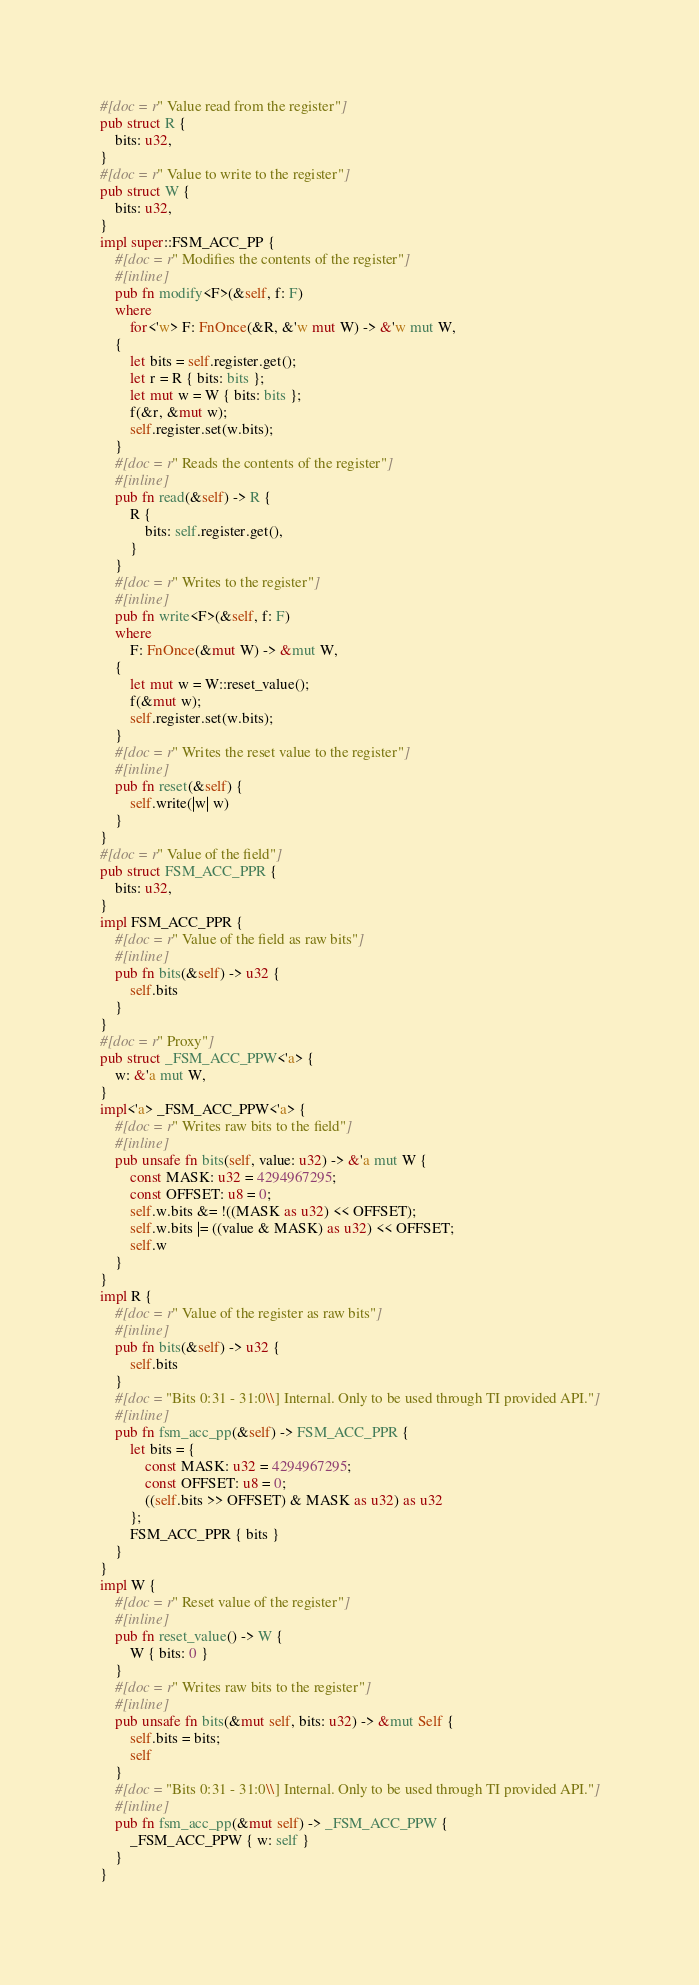<code> <loc_0><loc_0><loc_500><loc_500><_Rust_>#[doc = r" Value read from the register"]
pub struct R {
    bits: u32,
}
#[doc = r" Value to write to the register"]
pub struct W {
    bits: u32,
}
impl super::FSM_ACC_PP {
    #[doc = r" Modifies the contents of the register"]
    #[inline]
    pub fn modify<F>(&self, f: F)
    where
        for<'w> F: FnOnce(&R, &'w mut W) -> &'w mut W,
    {
        let bits = self.register.get();
        let r = R { bits: bits };
        let mut w = W { bits: bits };
        f(&r, &mut w);
        self.register.set(w.bits);
    }
    #[doc = r" Reads the contents of the register"]
    #[inline]
    pub fn read(&self) -> R {
        R {
            bits: self.register.get(),
        }
    }
    #[doc = r" Writes to the register"]
    #[inline]
    pub fn write<F>(&self, f: F)
    where
        F: FnOnce(&mut W) -> &mut W,
    {
        let mut w = W::reset_value();
        f(&mut w);
        self.register.set(w.bits);
    }
    #[doc = r" Writes the reset value to the register"]
    #[inline]
    pub fn reset(&self) {
        self.write(|w| w)
    }
}
#[doc = r" Value of the field"]
pub struct FSM_ACC_PPR {
    bits: u32,
}
impl FSM_ACC_PPR {
    #[doc = r" Value of the field as raw bits"]
    #[inline]
    pub fn bits(&self) -> u32 {
        self.bits
    }
}
#[doc = r" Proxy"]
pub struct _FSM_ACC_PPW<'a> {
    w: &'a mut W,
}
impl<'a> _FSM_ACC_PPW<'a> {
    #[doc = r" Writes raw bits to the field"]
    #[inline]
    pub unsafe fn bits(self, value: u32) -> &'a mut W {
        const MASK: u32 = 4294967295;
        const OFFSET: u8 = 0;
        self.w.bits &= !((MASK as u32) << OFFSET);
        self.w.bits |= ((value & MASK) as u32) << OFFSET;
        self.w
    }
}
impl R {
    #[doc = r" Value of the register as raw bits"]
    #[inline]
    pub fn bits(&self) -> u32 {
        self.bits
    }
    #[doc = "Bits 0:31 - 31:0\\] Internal. Only to be used through TI provided API."]
    #[inline]
    pub fn fsm_acc_pp(&self) -> FSM_ACC_PPR {
        let bits = {
            const MASK: u32 = 4294967295;
            const OFFSET: u8 = 0;
            ((self.bits >> OFFSET) & MASK as u32) as u32
        };
        FSM_ACC_PPR { bits }
    }
}
impl W {
    #[doc = r" Reset value of the register"]
    #[inline]
    pub fn reset_value() -> W {
        W { bits: 0 }
    }
    #[doc = r" Writes raw bits to the register"]
    #[inline]
    pub unsafe fn bits(&mut self, bits: u32) -> &mut Self {
        self.bits = bits;
        self
    }
    #[doc = "Bits 0:31 - 31:0\\] Internal. Only to be used through TI provided API."]
    #[inline]
    pub fn fsm_acc_pp(&mut self) -> _FSM_ACC_PPW {
        _FSM_ACC_PPW { w: self }
    }
}
</code> 